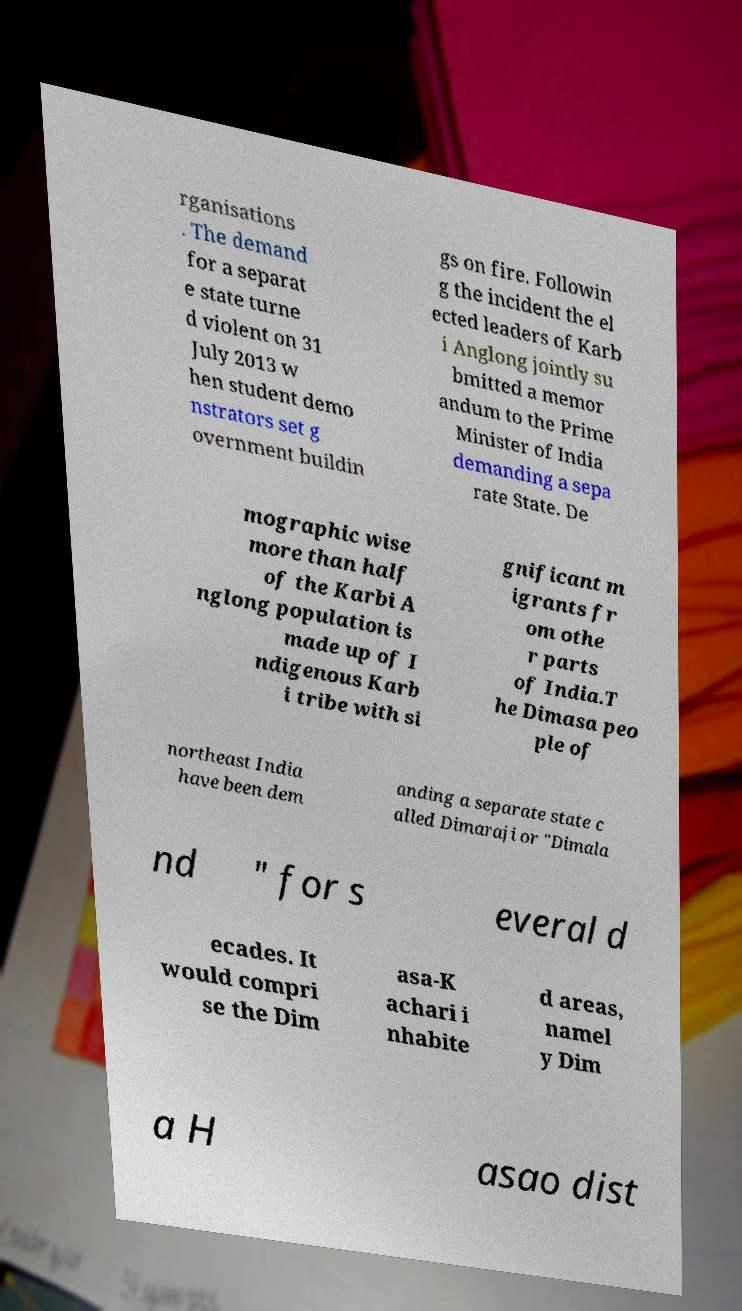I need the written content from this picture converted into text. Can you do that? rganisations . The demand for a separat e state turne d violent on 31 July 2013 w hen student demo nstrators set g overnment buildin gs on fire. Followin g the incident the el ected leaders of Karb i Anglong jointly su bmitted a memor andum to the Prime Minister of India demanding a sepa rate State. De mographic wise more than half of the Karbi A nglong population is made up of I ndigenous Karb i tribe with si gnificant m igrants fr om othe r parts of India.T he Dimasa peo ple of northeast India have been dem anding a separate state c alled Dimaraji or "Dimala nd " for s everal d ecades. It would compri se the Dim asa-K achari i nhabite d areas, namel y Dim a H asao dist 